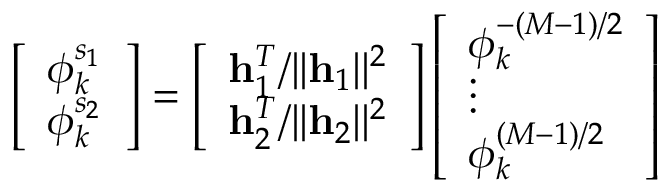<formula> <loc_0><loc_0><loc_500><loc_500>\left [ \begin{array} { l } { \phi _ { k } ^ { s _ { 1 } } } \\ { \phi _ { k } ^ { s _ { 2 } } } \end{array} \right ] = \left [ \begin{array} { l } { h _ { 1 } ^ { T } / | | h _ { 1 } | | ^ { 2 } } \\ { h _ { 2 } ^ { T } / | | h _ { 2 } | | ^ { 2 } } \end{array} \right ] \left [ \begin{array} { l } { \phi _ { k } ^ { - ( M - 1 ) / 2 } } \\ { \vdots } \\ { \phi _ { k } ^ { ( M - 1 ) / 2 } } \end{array} \right ]</formula> 